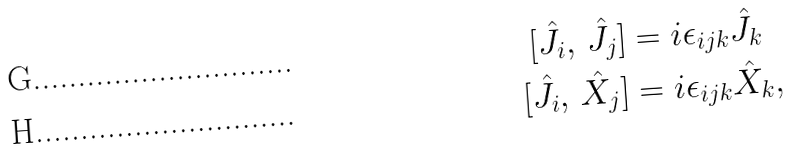Convert formula to latex. <formula><loc_0><loc_0><loc_500><loc_500>[ \hat { J } _ { i } , \, \hat { J } _ { j } ] & = i \epsilon _ { i j k } \hat { J } _ { k } \\ [ \hat { J } _ { i } , \, \hat { X } _ { j } ] & = i \epsilon _ { i j k } \hat { X } _ { k } ,</formula> 